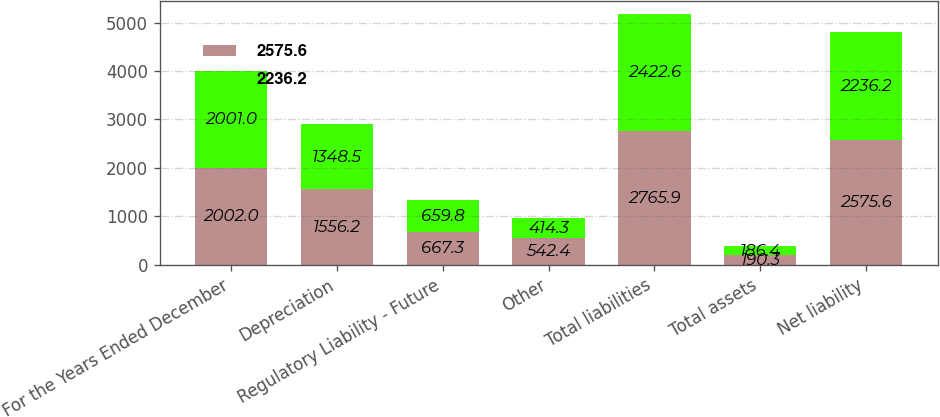<chart> <loc_0><loc_0><loc_500><loc_500><stacked_bar_chart><ecel><fcel>For the Years Ended December<fcel>Depreciation<fcel>Regulatory Liability - Future<fcel>Other<fcel>Total liabilities<fcel>Total assets<fcel>Net liability<nl><fcel>2575.6<fcel>2002<fcel>1556.2<fcel>667.3<fcel>542.4<fcel>2765.9<fcel>190.3<fcel>2575.6<nl><fcel>2236.2<fcel>2001<fcel>1348.5<fcel>659.8<fcel>414.3<fcel>2422.6<fcel>186.4<fcel>2236.2<nl></chart> 